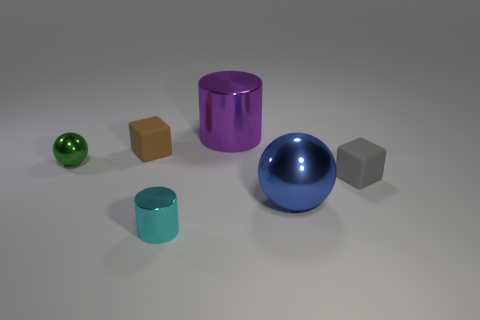Is there a big cyan shiny cylinder?
Provide a short and direct response. No. What material is the small cube that is on the right side of the large ball?
Keep it short and to the point. Rubber. How many tiny things are gray blocks or brown matte blocks?
Offer a very short reply. 2. What is the color of the large ball?
Provide a short and direct response. Blue. There is a large metal object that is on the right side of the purple object; are there any things that are right of it?
Offer a very short reply. Yes. Are there fewer large blue things that are left of the tiny green sphere than yellow blocks?
Provide a succinct answer. No. Is the material of the tiny object that is in front of the blue sphere the same as the small green object?
Your answer should be very brief. Yes. There is a big ball that is the same material as the small green sphere; what color is it?
Offer a very short reply. Blue. Is the number of small metallic cylinders on the right side of the tiny gray thing less than the number of tiny blocks that are behind the tiny green metal object?
Offer a very short reply. Yes. Is there a cyan thing that has the same material as the green object?
Provide a short and direct response. Yes. 